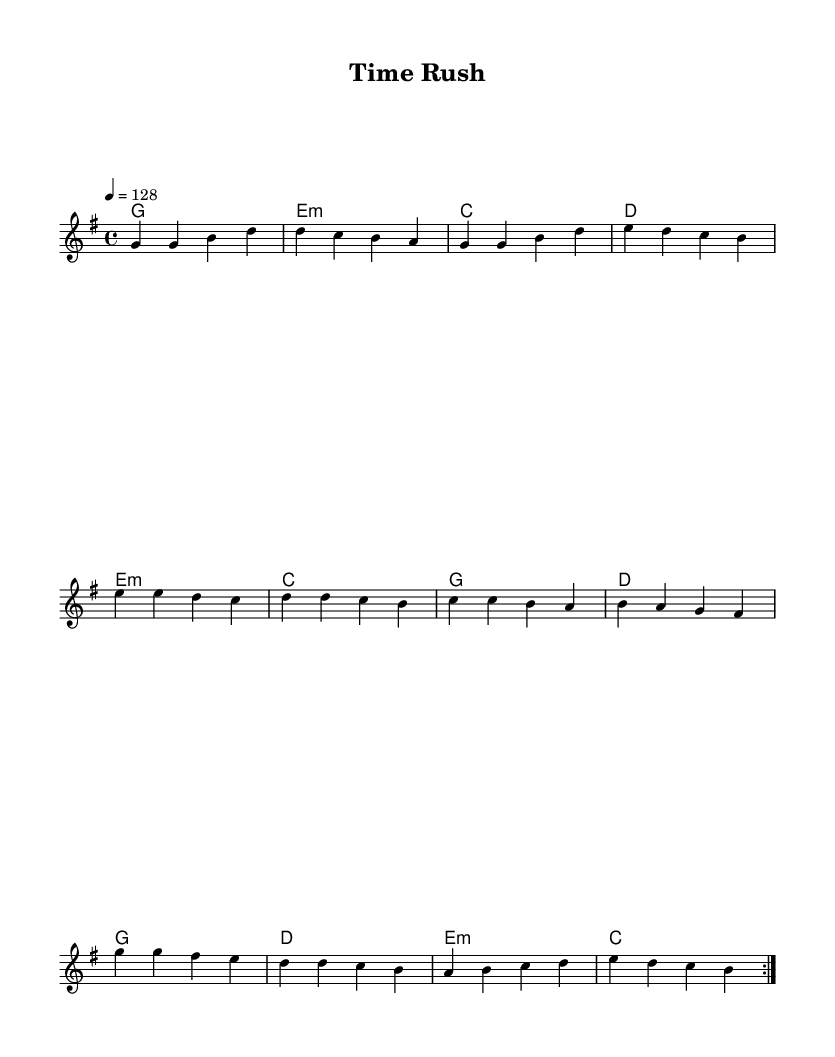What is the key signature of this music? The key signature is G major, as indicated by one sharp (F#) visible at the beginning of the staff.
Answer: G major What is the time signature of this music? The time signature is 4/4, which can be seen indicated at the beginning of the score. This means there are four beats in a measure.
Answer: 4/4 What is the tempo marking of this piece? The tempo marking indicates a speed of 128 beats per minute, as shown by the tempo instruction at the start of the score.
Answer: 128 How many measures are in a repeat section? The repeat section consists of two measures that are repeated, as indicated by the "volta" markings at the beginning of the section.
Answer: 2 What is the primary theme of this K-Pop track? The primary theme of this K-Pop track is likely related to time management and efficiency, inspired by the title "Time Rush" and the energetic nature of the music.
Answer: Time management Which section of the music is typically the most energetic? The chorus is typically the most energetic part of a K-Pop track, and in this case, it follows the pre-chorus and features a more upbeat and dynamic melody.
Answer: Chorus How many distinct sections are in the structure of this piece? There are three distinct sections in the structure: the verse, pre-chorus, and chorus, which are repeated in typical K-Pop fashion.
Answer: 3 